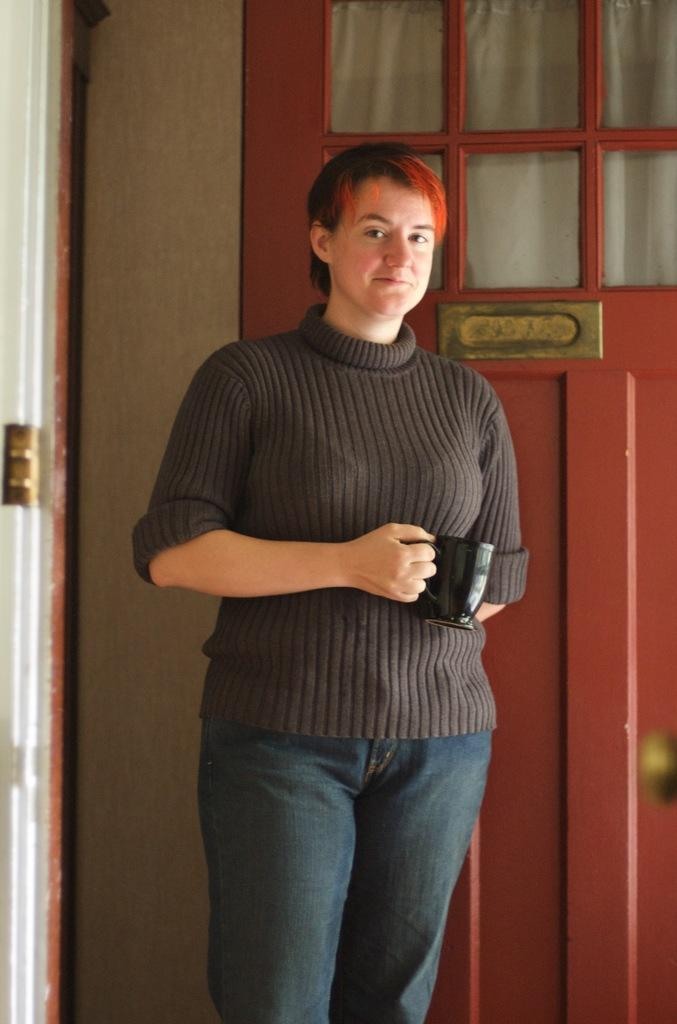Who is present in the image? There is a person in the image. What is the person holding in the image? The person is holding a cup. What is the color of the cup? The cup is black in color. What can be seen in the background of the image? There is a door and a wall in the background of the image. How many beds are visible in the image? There are no beds present in the image. Is there a sink in the image? There is no sink visible in the image. 